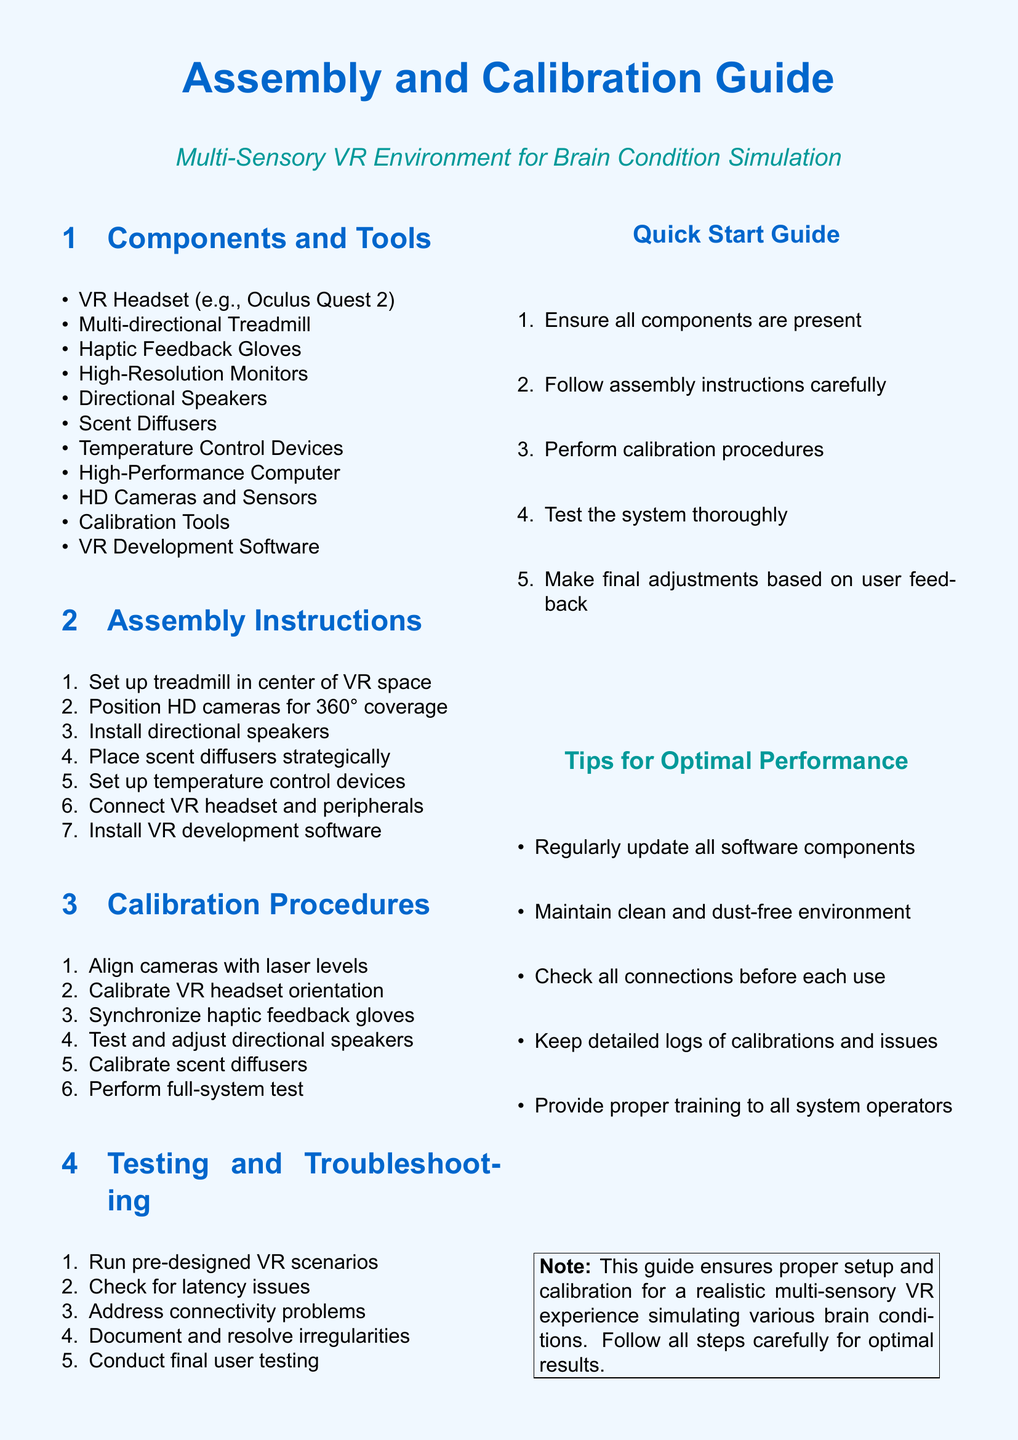What is the primary purpose of this guide? The guide provides instructions for setting up and calibrating a multi-sensory VR environment for simulating brain conditions.
Answer: setting up and calibrating a multi-sensory VR environment How many components are listed in the guide? The document contains a section that lists all the components necessary to set up the environment. It mentions ten components.
Answer: 10 What is the first step in the assembly instructions? The assembly instructions section outlines the steps needed to assemble the components, with the first step being the setup of the treadmill.
Answer: Set up treadmill in center of VR space What should be done after performing calibration procedures? After calibrating the components, the guide suggests testing the entire system to ensure functionality.
Answer: Test the system thoroughly Which device is used for haptic feedback? The document explicitly mentions the use of haptic gloves that provide tactile feedback in the VR experience.
Answer: Haptic Feedback Gloves What is the color used for headings in the document? The document specifies a color code for the headings, which is used consistently throughout the text.
Answer: RGB(0,102,204) How should the environment be maintained for optimal performance? The tips for optimal performance section advises maintaining a clean and dust-free environment for the system to function best.
Answer: Clean and dust-free environment Which section contains the troubleshooting steps? The troubleshooting process is listed under its dedicated section, focusing on methods to address issues in the VR setup.
Answer: Testing and Troubleshooting What software is required for the assembly process? The guide mentions the installation of specific software necessary for VR development to assemble the system correctly.
Answer: VR Development Software 